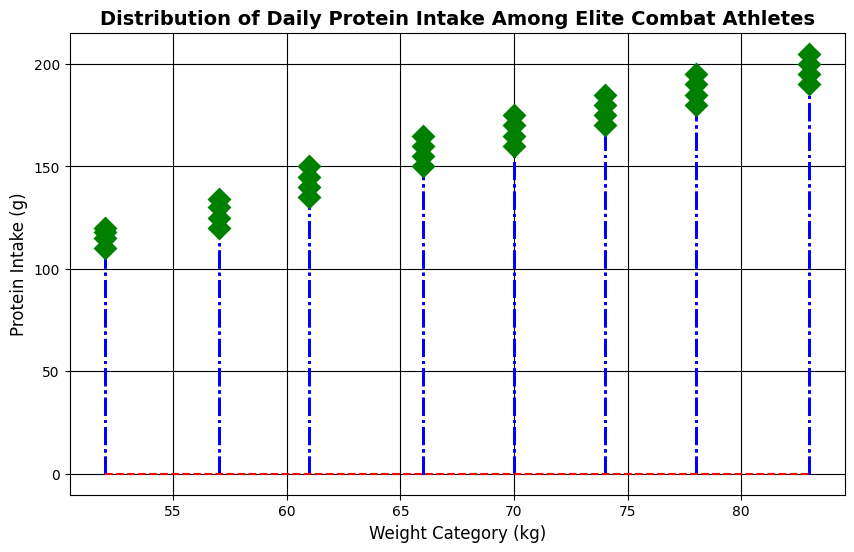What is the protein intake value of the lightest weight category? The lightest weight category listed is 52 kg. According to the plot, the protein intake values for this category are shown as markers at 110 g, 115 g, 118 g, and 120 g.
Answer: 110 g, 115 g, 118 g, 120 g What is the difference in the highest protein intake between the 52 kg and 83 kg categories? For the 52 kg category, the highest protein intake is 120 g. For the 83 kg category, the highest protein intake is 205 g. Subtracting these, 205 g - 120 g = 85 g.
Answer: 85 g How many weight categories show a maximum protein intake of 160 g or more? Reviewing the plot, the weight categories of 61 kg (150 g), 66 kg (165 g), 70 kg (175 g), 74 kg (185 g), 78 kg (195 g), and 83 kg (205 g) all have a maximum protein intake of 160 g or more.
Answer: 5 categories Which weight category has the least variation in daily protein intake values? The weight category with the least variation in protein intake values is 52 kg, where the protein intake ranges from 110 g to 120 g (only a 10 g range).
Answer: 52 kg What is the average protein intake for the weight category of 74 kg? The protein intake values for the 74 kg category are 170 g, 175 g, 180 g, and 185 g. The sum of these values is (170 + 175 + 180 + 185) = 710 g. Dividing by 4, the average intake is 710/4 = 177.5 g.
Answer: 177.5 g Which weight category has the highest maximum daily protein intake? Reviewing the plot, the highest maximum protein intake is observed for the 83 kg weight category with a value of 205 g.
Answer: 83 kg Does the 61 kg weight category have a higher average protein intake than the 57 kg category? For 61 kg, the protein intake values are 135 g, 140 g, 145 g, and 150 g, averaging (135 + 140 + 145 + 150)/4 = 142.5 g. For 57 kg, the values are 120 g, 125 g, 130 g, and 134 g, averaging (120 + 125 + 130 + 134)/4 = 127.25 g. Comparing these averages, 142.5 g is greater than 127.25 g.
Answer: Yes What is the range of the protein intake values for the 78 kg weight category? The protein intake values for the 78 kg weight category are 180 g, 185 g, 190 g, and 195 g. The range is calculated as the highest value minus the lowest value: 195 g - 180 g = 15 g.
Answer: 15 g How does the protein intake of the 70 kg category compare to that of the 66 kg category in terms of the median value? For the 70 kg category, the values are 160 g, 165 g, 170 g, and 175 g. The median value is (165 g + 170 g)/2 = 167.5 g. For the 66 kg category, the values are 150 g, 155 g, 160 g, and 165 g. The median value is (155 g + 160 g)/2 = 157.5 g. Comparing these, 167.5 g is greater than 157.5 g.
Answer: Higher in 70 kg 